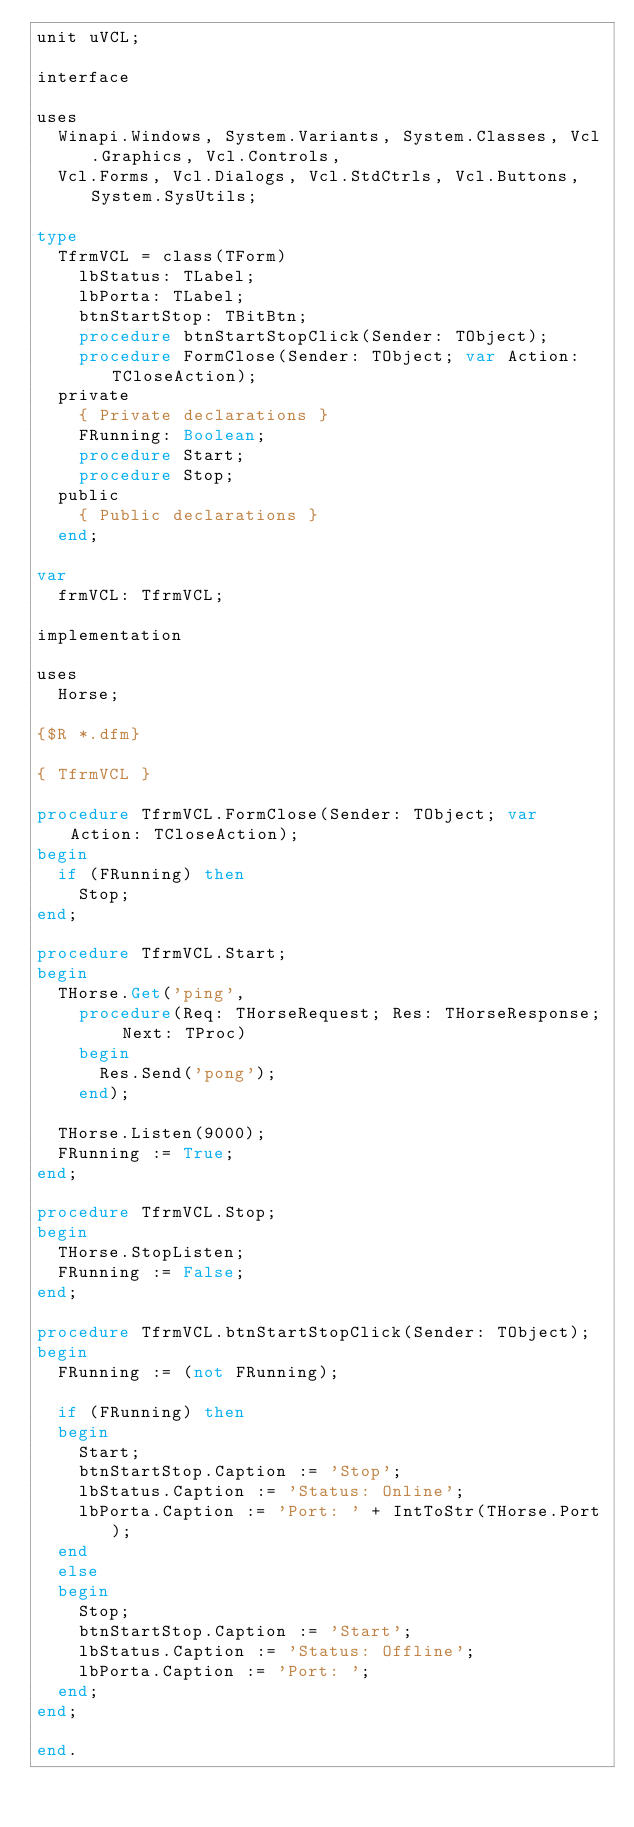Convert code to text. <code><loc_0><loc_0><loc_500><loc_500><_Pascal_>unit uVCL;

interface

uses
  Winapi.Windows, System.Variants, System.Classes, Vcl.Graphics, Vcl.Controls,
  Vcl.Forms, Vcl.Dialogs, Vcl.StdCtrls, Vcl.Buttons, System.SysUtils;

type
  TfrmVCL = class(TForm)
    lbStatus: TLabel;
    lbPorta: TLabel;
    btnStartStop: TBitBtn;
    procedure btnStartStopClick(Sender: TObject);
    procedure FormClose(Sender: TObject; var Action: TCloseAction);
  private
    { Private declarations }
    FRunning: Boolean;
    procedure Start;
    procedure Stop;
  public
    { Public declarations }
  end;

var
  frmVCL: TfrmVCL;

implementation

uses
  Horse;

{$R *.dfm}

{ TfrmVCL }

procedure TfrmVCL.FormClose(Sender: TObject; var Action: TCloseAction);
begin
  if (FRunning) then
    Stop;
end;

procedure TfrmVCL.Start;
begin
  THorse.Get('ping',
    procedure(Req: THorseRequest; Res: THorseResponse; Next: TProc)
    begin
      Res.Send('pong');
    end);

  THorse.Listen(9000);
  FRunning := True;
end;

procedure TfrmVCL.Stop;
begin
  THorse.StopListen;
  FRunning := False;
end;

procedure TfrmVCL.btnStartStopClick(Sender: TObject);
begin
  FRunning := (not FRunning);

  if (FRunning) then
  begin
    Start;
    btnStartStop.Caption := 'Stop';
    lbStatus.Caption := 'Status: Online';
    lbPorta.Caption := 'Port: ' + IntToStr(THorse.Port);
  end
  else
  begin
    Stop;
    btnStartStop.Caption := 'Start';
    lbStatus.Caption := 'Status: Offline';
    lbPorta.Caption := 'Port: ';
  end;
end;

end.
</code> 